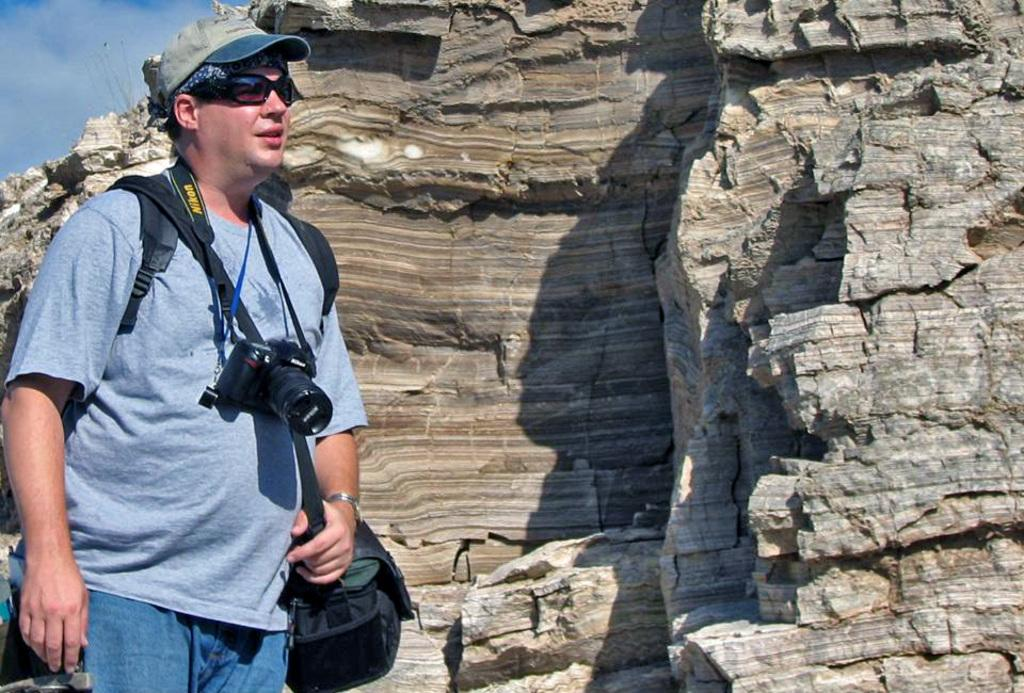What is the main subject of the image? There is a person standing in the image. What is the person wearing that is related to photography? The person is wearing a camera. What else is the person wearing that might be useful for carrying items? The person is wearing a backpack. What type of headwear is the person wearing? The person is wearing a cap. What type of eyewear is the person wearing? The person is wearing glasses. What can be seen in the background of the image? There is a rock and the sky visible in the background of the image. What is the condition of the sky in the image? Clouds are present in the sky. What type of alley can be seen in the image? There is no alley present in the image; it features a person standing with a rock and clouds in the background. 